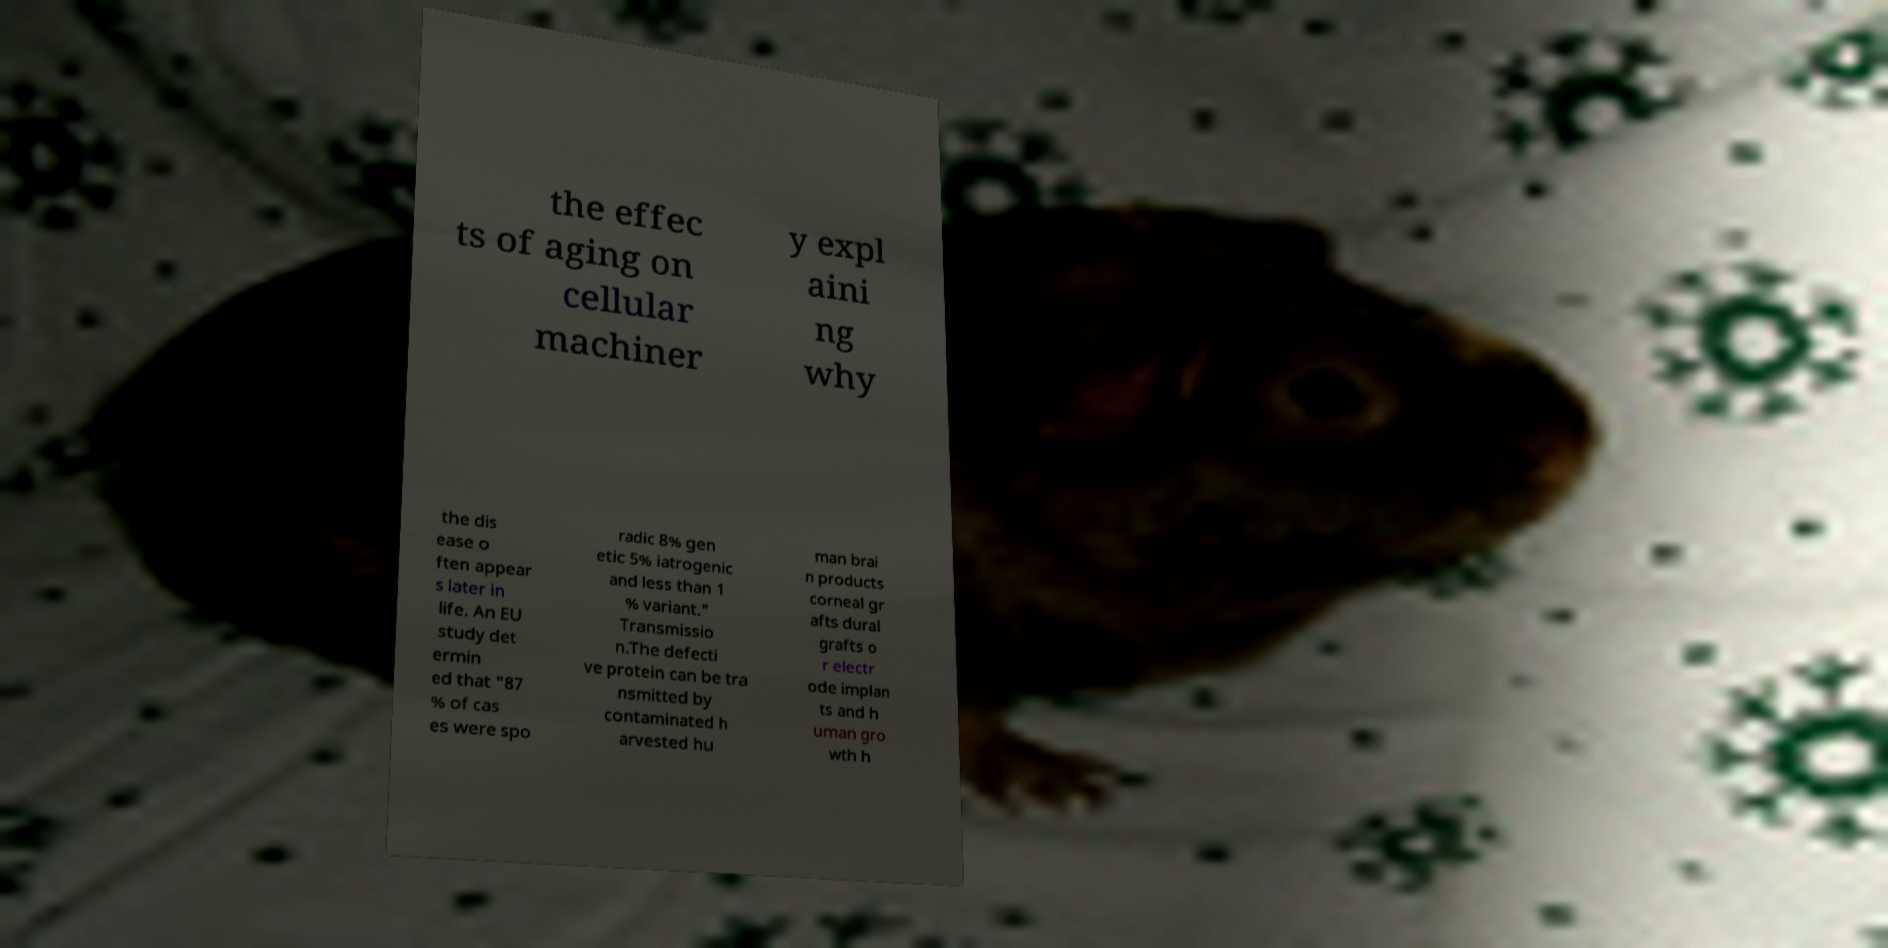I need the written content from this picture converted into text. Can you do that? the effec ts of aging on cellular machiner y expl aini ng why the dis ease o ften appear s later in life. An EU study det ermin ed that "87 % of cas es were spo radic 8% gen etic 5% iatrogenic and less than 1 % variant." Transmissio n.The defecti ve protein can be tra nsmitted by contaminated h arvested hu man brai n products corneal gr afts dural grafts o r electr ode implan ts and h uman gro wth h 